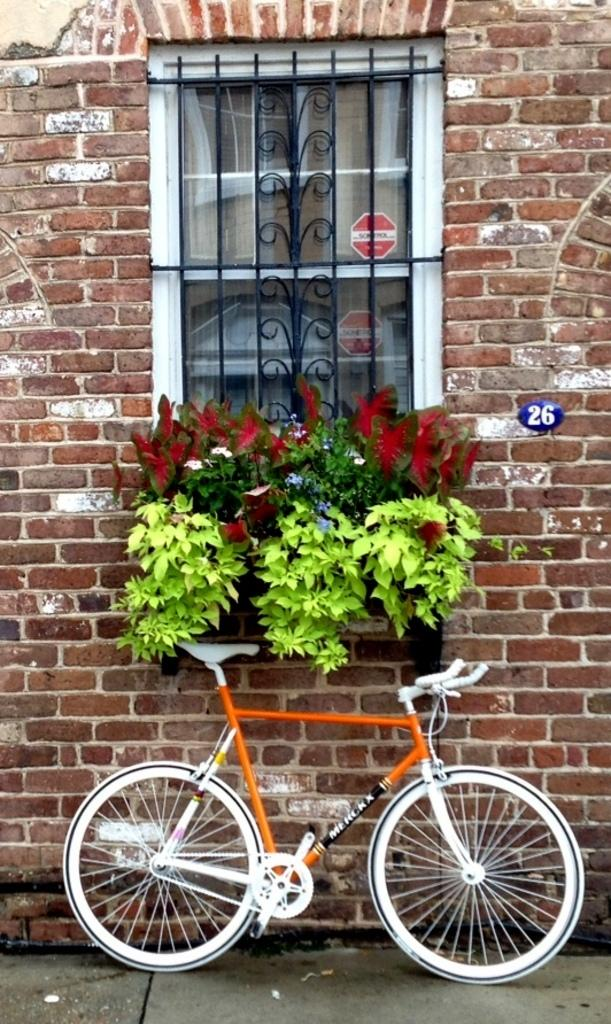What color is the bicycle in the image? The bicycle in the image is orange-white in color. What is behind the bicycle in the image? There is a wall behind the bicycle in the image. What feature can be seen in the middle of the wall? A window is present in the middle of the wall. What is in front of the window in the image? There are plants in front of the window in the image. What type of cloth is being used to make the bicycle's seat in the image? The image does not provide information about the material used for the bicycle's seat, so we cannot determine if it is made of cloth. 